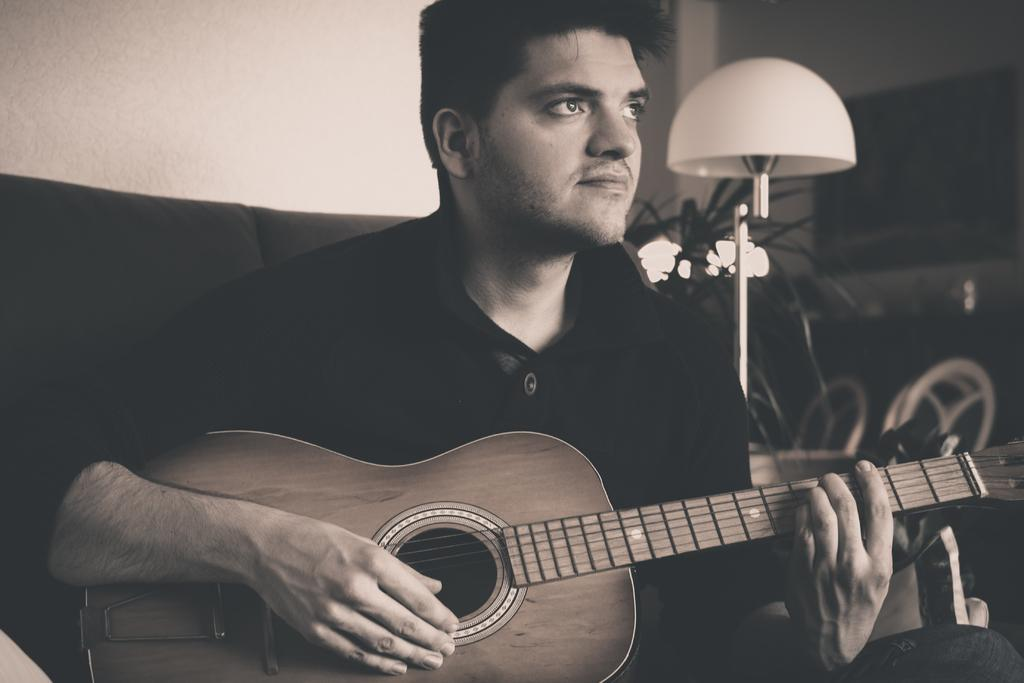Who is the main subject in the image? There is a man in the image. What is the man doing in the image? The man is playing a guitar. Where is the man sitting in the image? The man is sitting on a sofa. What other object can be seen in the image? There is a lamp in the image. In which direction is the group of people walking in the image? There is no group of people walking in the image; it only features a man playing a guitar. 